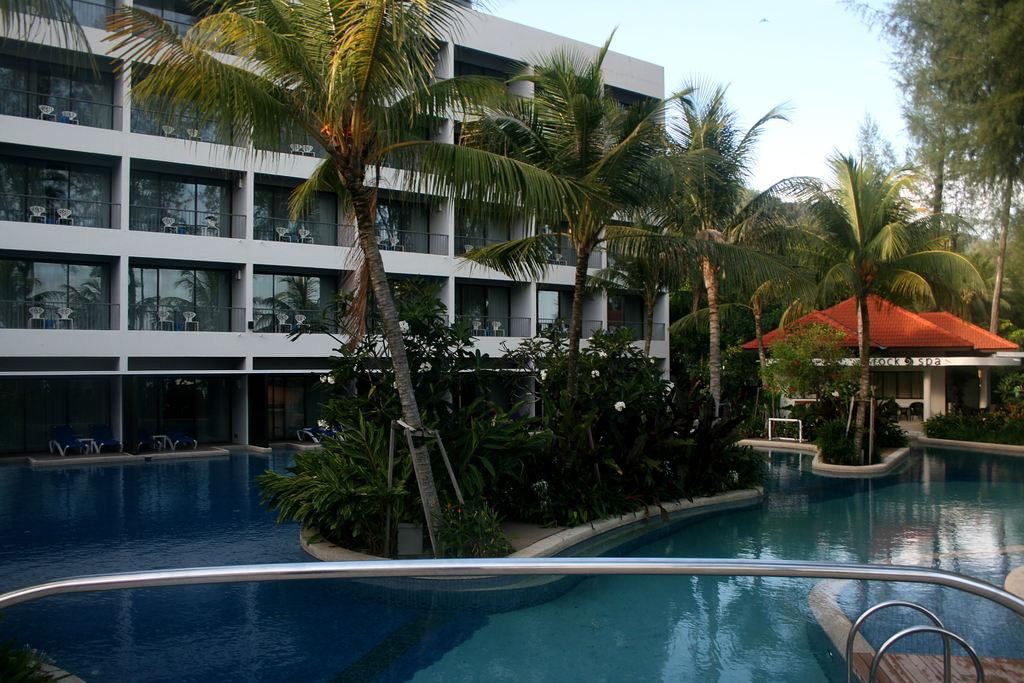What type of vegetation can be seen in the image? There are trees in the image. What recreational feature is present in the image? There is a swimming pool in the image. What type of structures are visible in the image? There are buildings in the image. What is visible in the background of the image? The sky is visible behind the buildings. What material can be seen at the bottom of the image? Iron rods are present at the bottom of the image. Can you tell me which type of berry is growing on the trees in the image? There is no information about berries or any specific type of vegetation on the trees in the image. 